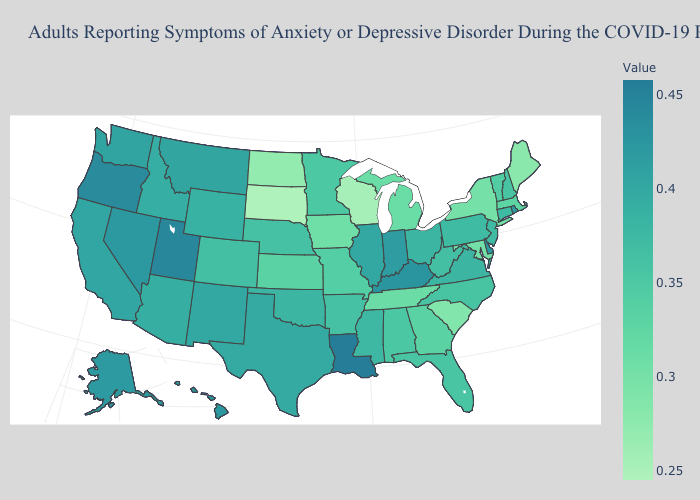Is the legend a continuous bar?
Be succinct. Yes. Does the map have missing data?
Keep it brief. No. Among the states that border Louisiana , does Arkansas have the highest value?
Keep it brief. No. 